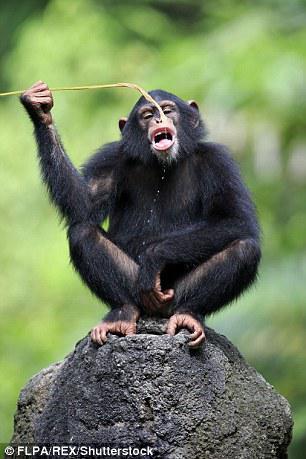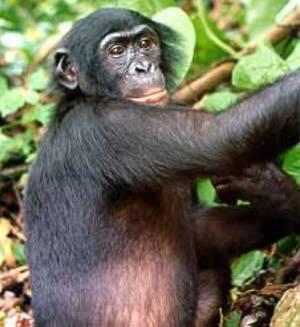The first image is the image on the left, the second image is the image on the right. Examine the images to the left and right. Is the description "In one image there is a lone monkey with an open mouth like it is howling." accurate? Answer yes or no. No. The first image is the image on the left, the second image is the image on the right. Examine the images to the left and right. Is the description "in the right image a chimp is making an O with it's mouth" accurate? Answer yes or no. No. 